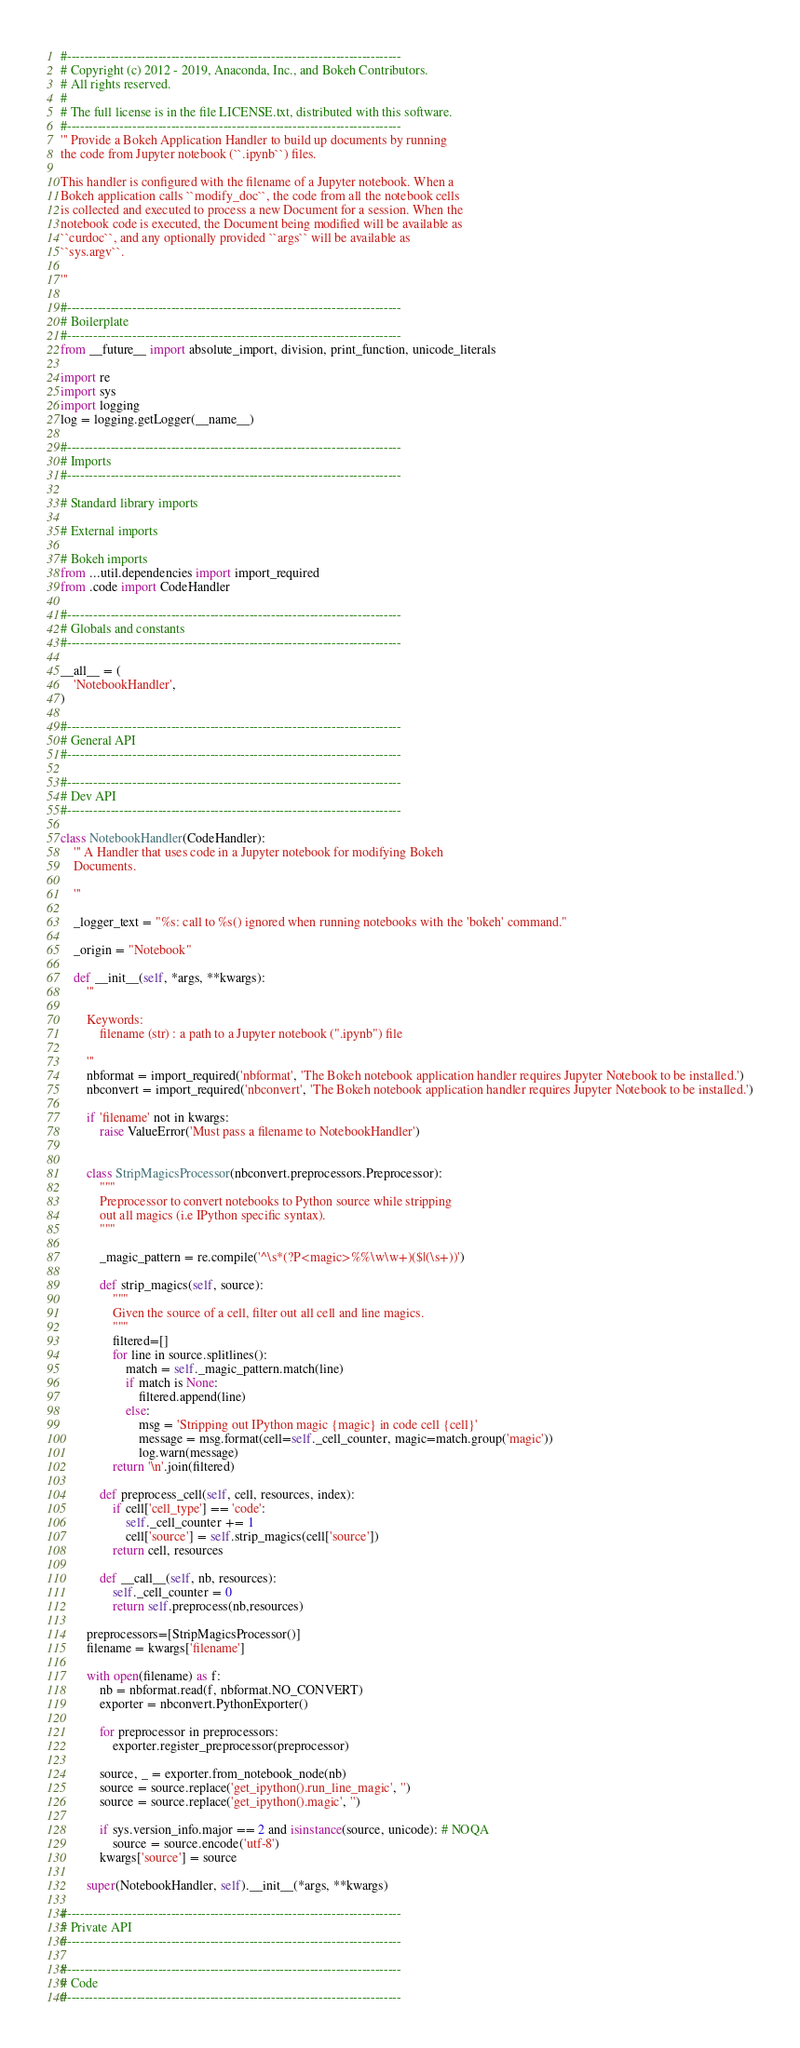Convert code to text. <code><loc_0><loc_0><loc_500><loc_500><_Python_>#-----------------------------------------------------------------------------
# Copyright (c) 2012 - 2019, Anaconda, Inc., and Bokeh Contributors.
# All rights reserved.
#
# The full license is in the file LICENSE.txt, distributed with this software.
#-----------------------------------------------------------------------------
''' Provide a Bokeh Application Handler to build up documents by running
the code from Jupyter notebook (``.ipynb``) files.

This handler is configured with the filename of a Jupyter notebook. When a
Bokeh application calls ``modify_doc``, the code from all the notebook cells
is collected and executed to process a new Document for a session. When the
notebook code is executed, the Document being modified will be available as
``curdoc``, and any optionally provided ``args`` will be available as
``sys.argv``.

'''

#-----------------------------------------------------------------------------
# Boilerplate
#-----------------------------------------------------------------------------
from __future__ import absolute_import, division, print_function, unicode_literals

import re
import sys
import logging
log = logging.getLogger(__name__)

#-----------------------------------------------------------------------------
# Imports
#-----------------------------------------------------------------------------

# Standard library imports

# External imports

# Bokeh imports
from ...util.dependencies import import_required
from .code import CodeHandler

#-----------------------------------------------------------------------------
# Globals and constants
#-----------------------------------------------------------------------------

__all__ = (
    'NotebookHandler',
)

#-----------------------------------------------------------------------------
# General API
#-----------------------------------------------------------------------------

#-----------------------------------------------------------------------------
# Dev API
#-----------------------------------------------------------------------------

class NotebookHandler(CodeHandler):
    ''' A Handler that uses code in a Jupyter notebook for modifying Bokeh
    Documents.

    '''

    _logger_text = "%s: call to %s() ignored when running notebooks with the 'bokeh' command."

    _origin = "Notebook"

    def __init__(self, *args, **kwargs):
        '''

        Keywords:
            filename (str) : a path to a Jupyter notebook (".ipynb") file

        '''
        nbformat = import_required('nbformat', 'The Bokeh notebook application handler requires Jupyter Notebook to be installed.')
        nbconvert = import_required('nbconvert', 'The Bokeh notebook application handler requires Jupyter Notebook to be installed.')

        if 'filename' not in kwargs:
            raise ValueError('Must pass a filename to NotebookHandler')


        class StripMagicsProcessor(nbconvert.preprocessors.Preprocessor):
            """
            Preprocessor to convert notebooks to Python source while stripping
            out all magics (i.e IPython specific syntax).
            """

            _magic_pattern = re.compile('^\s*(?P<magic>%%\w\w+)($|(\s+))')

            def strip_magics(self, source):
                """
                Given the source of a cell, filter out all cell and line magics.
                """
                filtered=[]
                for line in source.splitlines():
                    match = self._magic_pattern.match(line)
                    if match is None:
                        filtered.append(line)
                    else:
                        msg = 'Stripping out IPython magic {magic} in code cell {cell}'
                        message = msg.format(cell=self._cell_counter, magic=match.group('magic'))
                        log.warn(message)
                return '\n'.join(filtered)

            def preprocess_cell(self, cell, resources, index):
                if cell['cell_type'] == 'code':
                    self._cell_counter += 1
                    cell['source'] = self.strip_magics(cell['source'])
                return cell, resources

            def __call__(self, nb, resources):
                self._cell_counter = 0
                return self.preprocess(nb,resources)

        preprocessors=[StripMagicsProcessor()]
        filename = kwargs['filename']

        with open(filename) as f:
            nb = nbformat.read(f, nbformat.NO_CONVERT)
            exporter = nbconvert.PythonExporter()

            for preprocessor in preprocessors:
                exporter.register_preprocessor(preprocessor)

            source, _ = exporter.from_notebook_node(nb)
            source = source.replace('get_ipython().run_line_magic', '')
            source = source.replace('get_ipython().magic', '')

            if sys.version_info.major == 2 and isinstance(source, unicode): # NOQA
                source = source.encode('utf-8')
            kwargs['source'] = source

        super(NotebookHandler, self).__init__(*args, **kwargs)

#-----------------------------------------------------------------------------
# Private API
#-----------------------------------------------------------------------------

#-----------------------------------------------------------------------------
# Code
#-----------------------------------------------------------------------------
</code> 